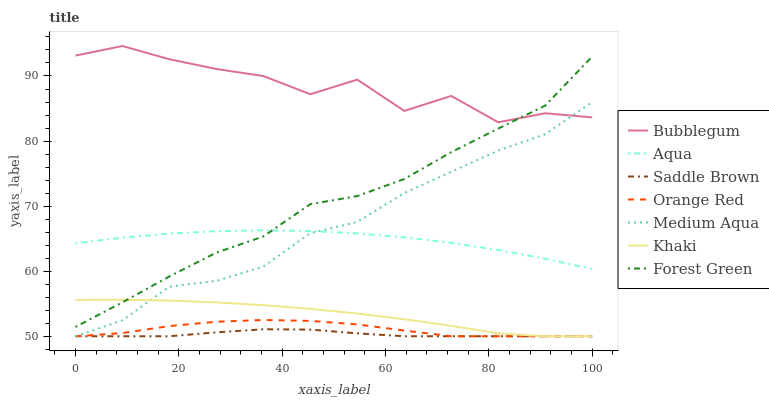Does Saddle Brown have the minimum area under the curve?
Answer yes or no. Yes. Does Bubblegum have the maximum area under the curve?
Answer yes or no. Yes. Does Aqua have the minimum area under the curve?
Answer yes or no. No. Does Aqua have the maximum area under the curve?
Answer yes or no. No. Is Khaki the smoothest?
Answer yes or no. Yes. Is Bubblegum the roughest?
Answer yes or no. Yes. Is Aqua the smoothest?
Answer yes or no. No. Is Aqua the roughest?
Answer yes or no. No. Does Khaki have the lowest value?
Answer yes or no. Yes. Does Aqua have the lowest value?
Answer yes or no. No. Does Bubblegum have the highest value?
Answer yes or no. Yes. Does Aqua have the highest value?
Answer yes or no. No. Is Khaki less than Bubblegum?
Answer yes or no. Yes. Is Bubblegum greater than Aqua?
Answer yes or no. Yes. Does Medium Aqua intersect Orange Red?
Answer yes or no. Yes. Is Medium Aqua less than Orange Red?
Answer yes or no. No. Is Medium Aqua greater than Orange Red?
Answer yes or no. No. Does Khaki intersect Bubblegum?
Answer yes or no. No. 